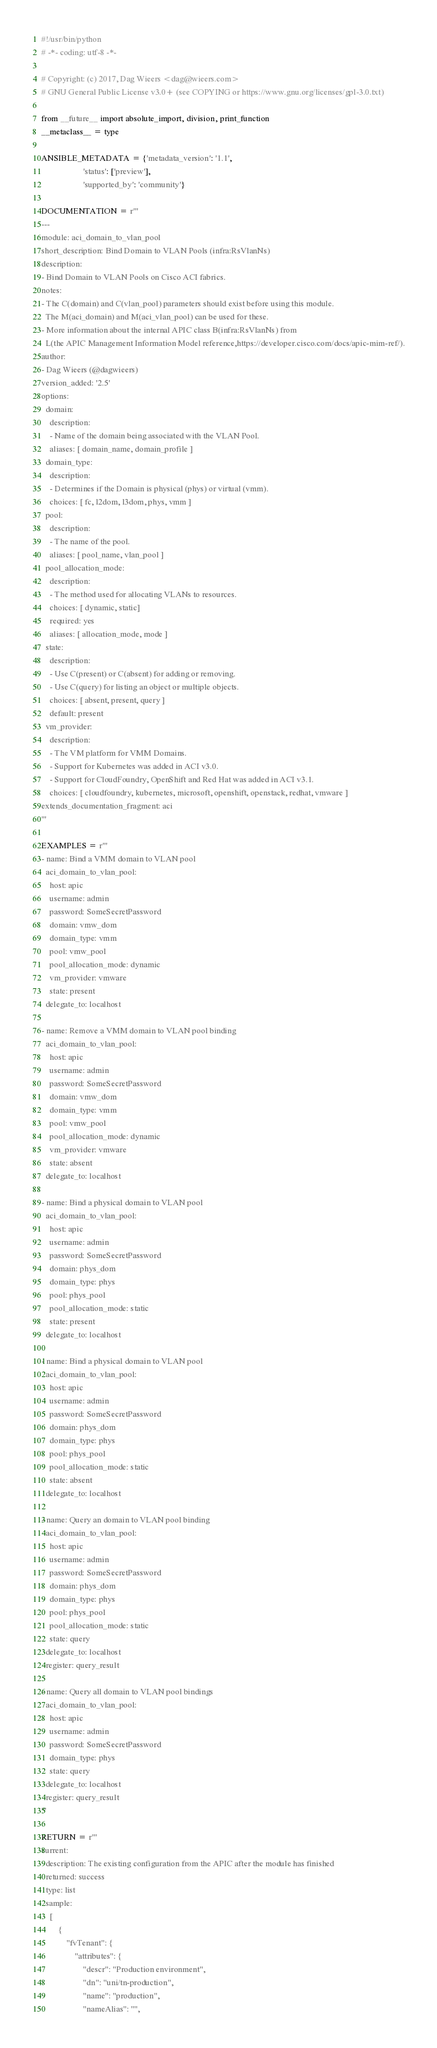<code> <loc_0><loc_0><loc_500><loc_500><_Python_>#!/usr/bin/python
# -*- coding: utf-8 -*-

# Copyright: (c) 2017, Dag Wieers <dag@wieers.com>
# GNU General Public License v3.0+ (see COPYING or https://www.gnu.org/licenses/gpl-3.0.txt)

from __future__ import absolute_import, division, print_function
__metaclass__ = type

ANSIBLE_METADATA = {'metadata_version': '1.1',
                    'status': ['preview'],
                    'supported_by': 'community'}

DOCUMENTATION = r'''
---
module: aci_domain_to_vlan_pool
short_description: Bind Domain to VLAN Pools (infra:RsVlanNs)
description:
- Bind Domain to VLAN Pools on Cisco ACI fabrics.
notes:
- The C(domain) and C(vlan_pool) parameters should exist before using this module.
  The M(aci_domain) and M(aci_vlan_pool) can be used for these.
- More information about the internal APIC class B(infra:RsVlanNs) from
  L(the APIC Management Information Model reference,https://developer.cisco.com/docs/apic-mim-ref/).
author:
- Dag Wieers (@dagwieers)
version_added: '2.5'
options:
  domain:
    description:
    - Name of the domain being associated with the VLAN Pool.
    aliases: [ domain_name, domain_profile ]
  domain_type:
    description:
    - Determines if the Domain is physical (phys) or virtual (vmm).
    choices: [ fc, l2dom, l3dom, phys, vmm ]
  pool:
    description:
    - The name of the pool.
    aliases: [ pool_name, vlan_pool ]
  pool_allocation_mode:
    description:
    - The method used for allocating VLANs to resources.
    choices: [ dynamic, static]
    required: yes
    aliases: [ allocation_mode, mode ]
  state:
    description:
    - Use C(present) or C(absent) for adding or removing.
    - Use C(query) for listing an object or multiple objects.
    choices: [ absent, present, query ]
    default: present
  vm_provider:
    description:
    - The VM platform for VMM Domains.
    - Support for Kubernetes was added in ACI v3.0.
    - Support for CloudFoundry, OpenShift and Red Hat was added in ACI v3.1.
    choices: [ cloudfoundry, kubernetes, microsoft, openshift, openstack, redhat, vmware ]
extends_documentation_fragment: aci
'''

EXAMPLES = r'''
- name: Bind a VMM domain to VLAN pool
  aci_domain_to_vlan_pool:
    host: apic
    username: admin
    password: SomeSecretPassword
    domain: vmw_dom
    domain_type: vmm
    pool: vmw_pool
    pool_allocation_mode: dynamic
    vm_provider: vmware
    state: present
  delegate_to: localhost

- name: Remove a VMM domain to VLAN pool binding
  aci_domain_to_vlan_pool:
    host: apic
    username: admin
    password: SomeSecretPassword
    domain: vmw_dom
    domain_type: vmm
    pool: vmw_pool
    pool_allocation_mode: dynamic
    vm_provider: vmware
    state: absent
  delegate_to: localhost

- name: Bind a physical domain to VLAN pool
  aci_domain_to_vlan_pool:
    host: apic
    username: admin
    password: SomeSecretPassword
    domain: phys_dom
    domain_type: phys
    pool: phys_pool
    pool_allocation_mode: static
    state: present
  delegate_to: localhost

- name: Bind a physical domain to VLAN pool
  aci_domain_to_vlan_pool:
    host: apic
    username: admin
    password: SomeSecretPassword
    domain: phys_dom
    domain_type: phys
    pool: phys_pool
    pool_allocation_mode: static
    state: absent
  delegate_to: localhost

- name: Query an domain to VLAN pool binding
  aci_domain_to_vlan_pool:
    host: apic
    username: admin
    password: SomeSecretPassword
    domain: phys_dom
    domain_type: phys
    pool: phys_pool
    pool_allocation_mode: static
    state: query
  delegate_to: localhost
  register: query_result

- name: Query all domain to VLAN pool bindings
  aci_domain_to_vlan_pool:
    host: apic
    username: admin
    password: SomeSecretPassword
    domain_type: phys
    state: query
  delegate_to: localhost
  register: query_result
'''

RETURN = r'''
current:
  description: The existing configuration from the APIC after the module has finished
  returned: success
  type: list
  sample:
    [
        {
            "fvTenant": {
                "attributes": {
                    "descr": "Production environment",
                    "dn": "uni/tn-production",
                    "name": "production",
                    "nameAlias": "",</code> 